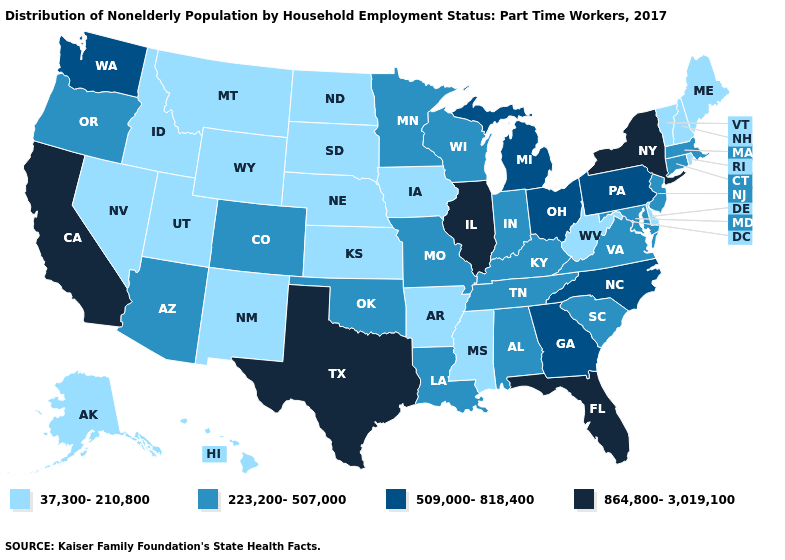Does Arkansas have the highest value in the South?
Give a very brief answer. No. Does Indiana have a lower value than Vermont?
Answer briefly. No. Among the states that border Minnesota , which have the lowest value?
Keep it brief. Iowa, North Dakota, South Dakota. Does California have the highest value in the USA?
Concise answer only. Yes. Does Vermont have the lowest value in the USA?
Short answer required. Yes. Does the map have missing data?
Give a very brief answer. No. Name the states that have a value in the range 864,800-3,019,100?
Be succinct. California, Florida, Illinois, New York, Texas. Does Hawaii have the same value as Indiana?
Keep it brief. No. Name the states that have a value in the range 864,800-3,019,100?
Write a very short answer. California, Florida, Illinois, New York, Texas. Name the states that have a value in the range 509,000-818,400?
Keep it brief. Georgia, Michigan, North Carolina, Ohio, Pennsylvania, Washington. What is the value of Arkansas?
Answer briefly. 37,300-210,800. What is the highest value in states that border Iowa?
Quick response, please. 864,800-3,019,100. Does New Jersey have the lowest value in the USA?
Give a very brief answer. No. Does the first symbol in the legend represent the smallest category?
Answer briefly. Yes. Does Texas have the highest value in the South?
Concise answer only. Yes. 